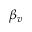Convert formula to latex. <formula><loc_0><loc_0><loc_500><loc_500>\beta _ { v }</formula> 